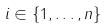Convert formula to latex. <formula><loc_0><loc_0><loc_500><loc_500>i \in \{ 1 , \dots , n \}</formula> 